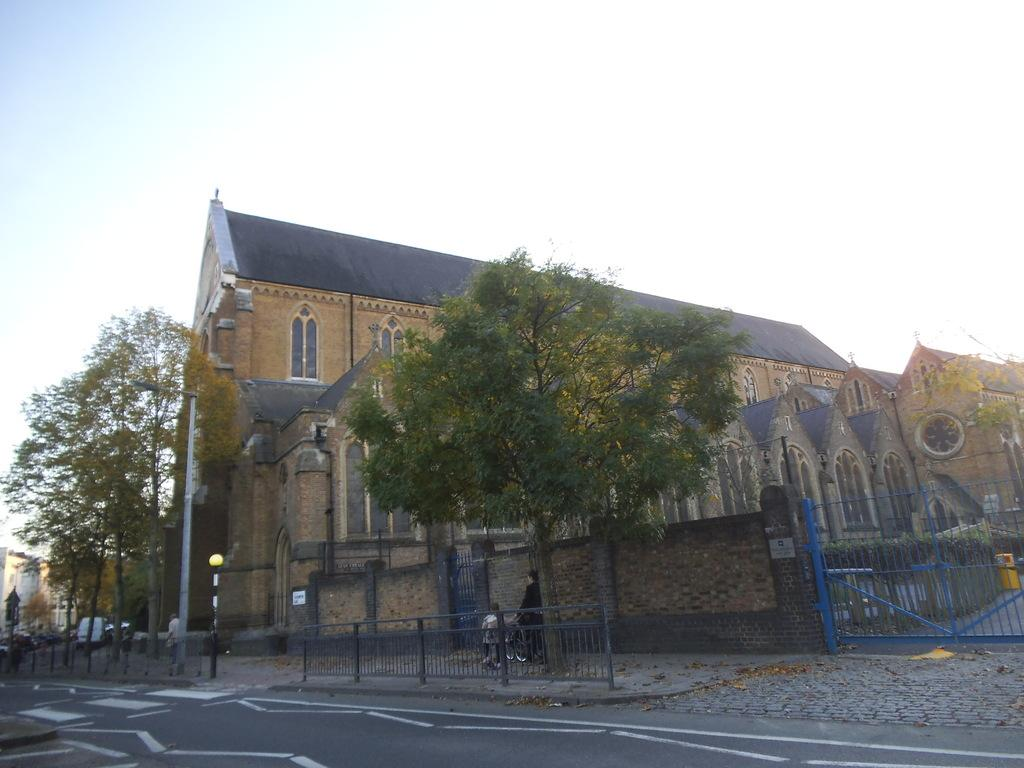What type of structures can be seen in the image? There are buildings in the image. What other natural or man-made elements are present in the image? There are trees, a railing, street lights, poles, a gate, and a road in the image. Are there any people visible in the image? Yes, there are people in the image. What is visible at the top of the image? The sky is visible at the top of the image. What is the name of the marble statue in the image? There is no marble statue present in the image. What design is featured on the gate in the image? The image does not provide enough detail to describe the design on the gate. 